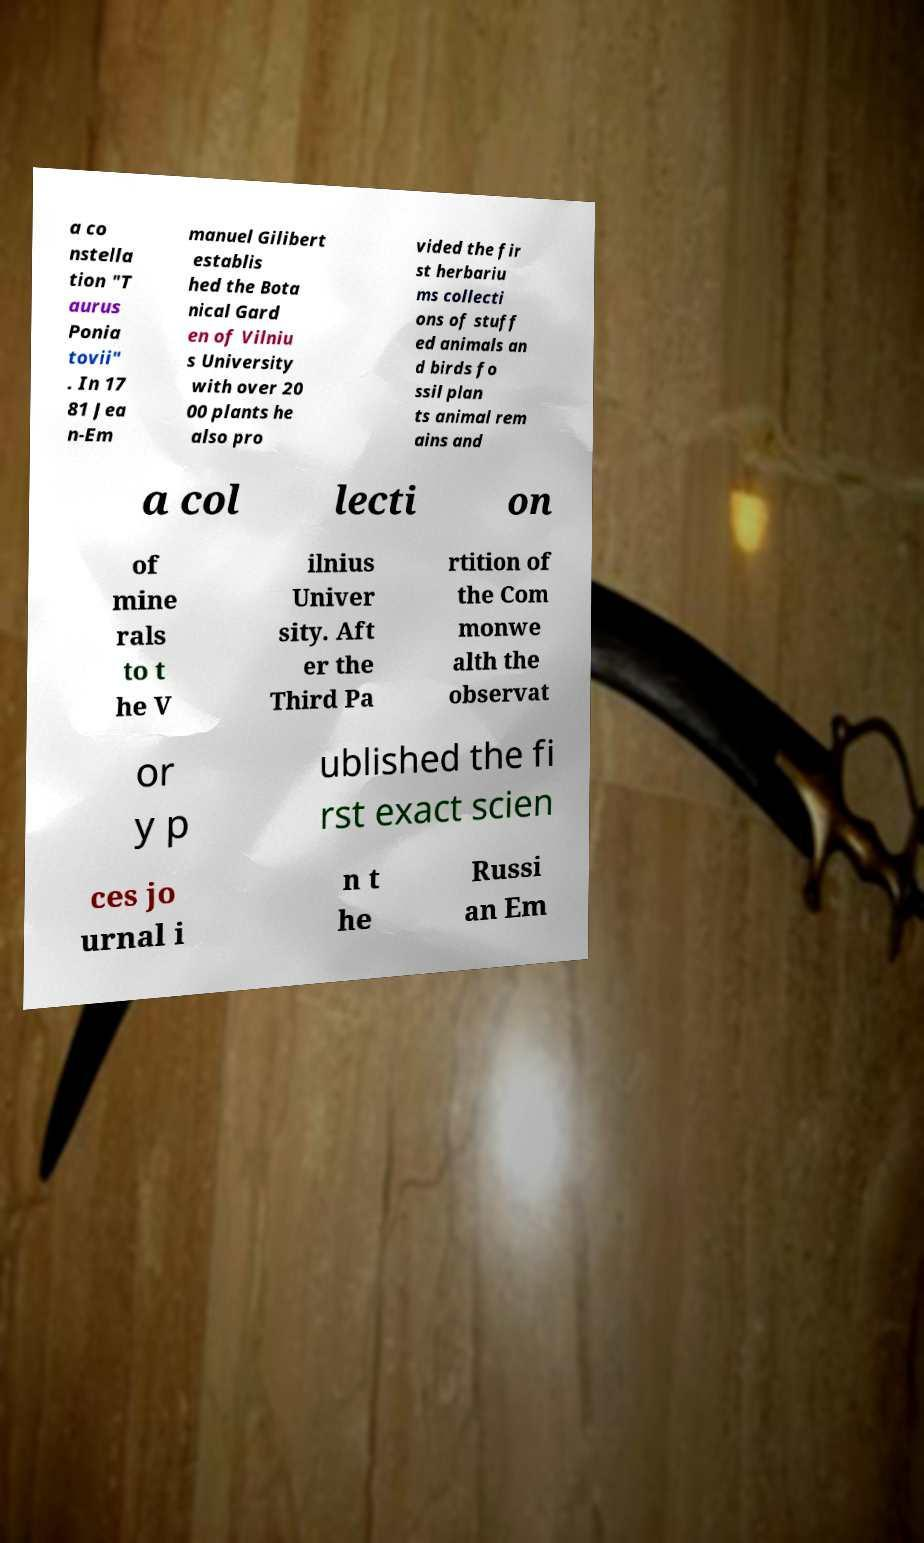There's text embedded in this image that I need extracted. Can you transcribe it verbatim? a co nstella tion "T aurus Ponia tovii" . In 17 81 Jea n-Em manuel Gilibert establis hed the Bota nical Gard en of Vilniu s University with over 20 00 plants he also pro vided the fir st herbariu ms collecti ons of stuff ed animals an d birds fo ssil plan ts animal rem ains and a col lecti on of mine rals to t he V ilnius Univer sity. Aft er the Third Pa rtition of the Com monwe alth the observat or y p ublished the fi rst exact scien ces jo urnal i n t he Russi an Em 